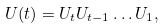<formula> <loc_0><loc_0><loc_500><loc_500>U ( t ) = U _ { t } U _ { t - 1 } \dots U _ { 1 } ,</formula> 